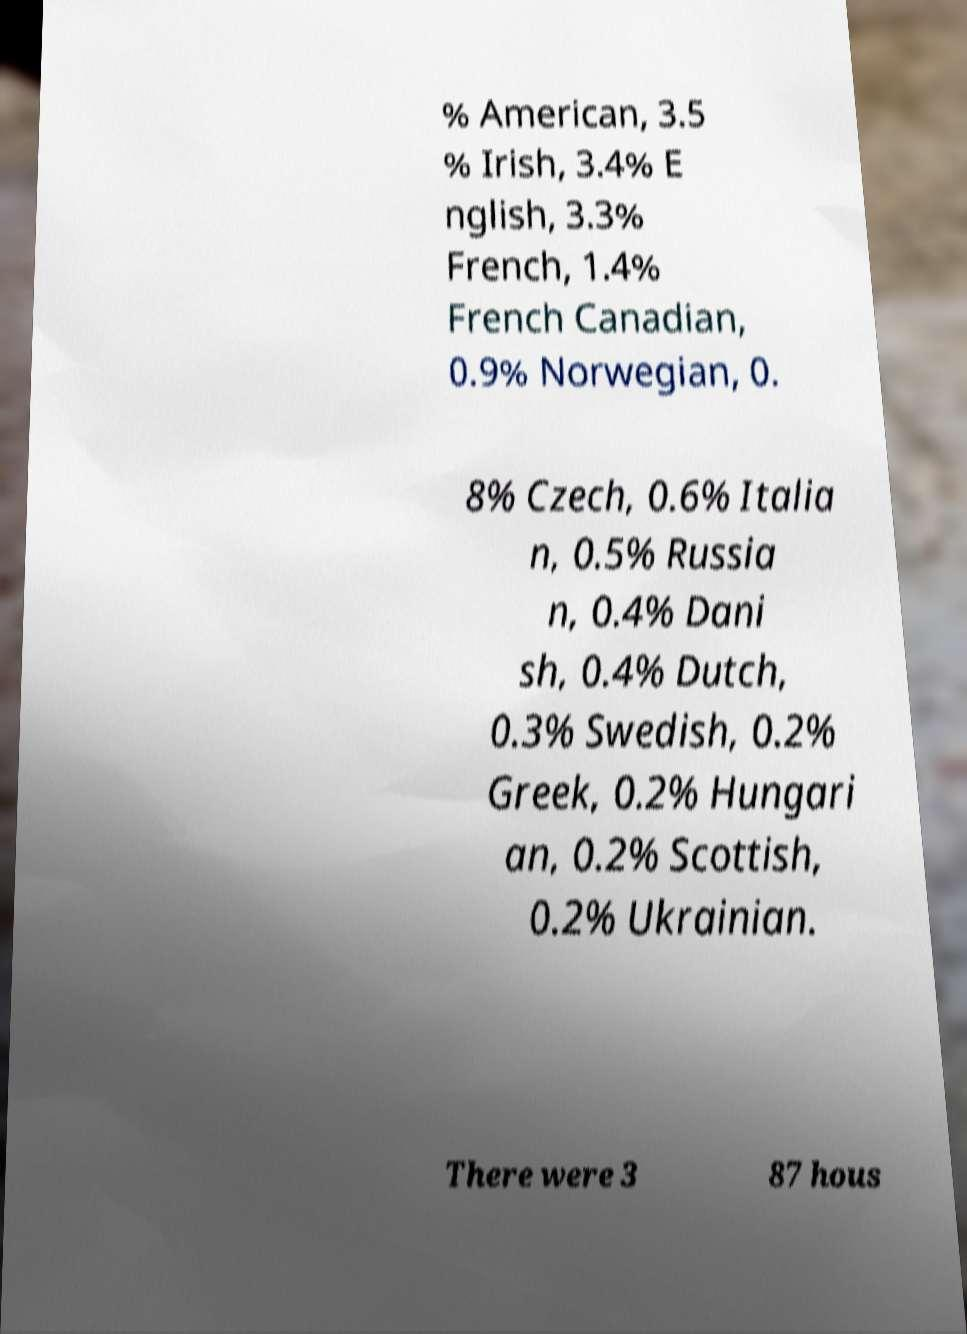Can you read and provide the text displayed in the image?This photo seems to have some interesting text. Can you extract and type it out for me? % American, 3.5 % Irish, 3.4% E nglish, 3.3% French, 1.4% French Canadian, 0.9% Norwegian, 0. 8% Czech, 0.6% Italia n, 0.5% Russia n, 0.4% Dani sh, 0.4% Dutch, 0.3% Swedish, 0.2% Greek, 0.2% Hungari an, 0.2% Scottish, 0.2% Ukrainian. There were 3 87 hous 